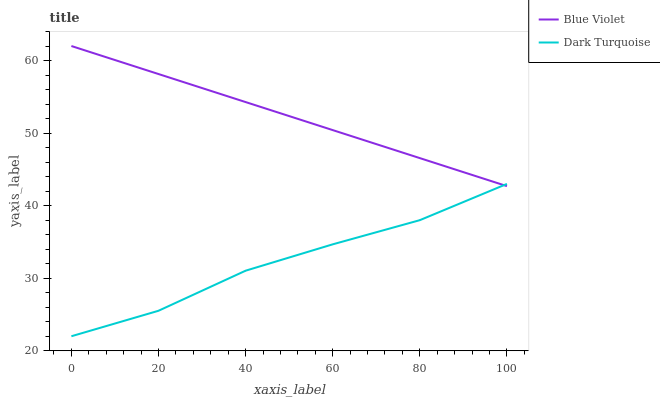Does Dark Turquoise have the minimum area under the curve?
Answer yes or no. Yes. Does Blue Violet have the maximum area under the curve?
Answer yes or no. Yes. Does Blue Violet have the minimum area under the curve?
Answer yes or no. No. Is Blue Violet the smoothest?
Answer yes or no. Yes. Is Dark Turquoise the roughest?
Answer yes or no. Yes. Is Blue Violet the roughest?
Answer yes or no. No. Does Dark Turquoise have the lowest value?
Answer yes or no. Yes. Does Blue Violet have the lowest value?
Answer yes or no. No. Does Blue Violet have the highest value?
Answer yes or no. Yes. Does Dark Turquoise intersect Blue Violet?
Answer yes or no. Yes. Is Dark Turquoise less than Blue Violet?
Answer yes or no. No. Is Dark Turquoise greater than Blue Violet?
Answer yes or no. No. 